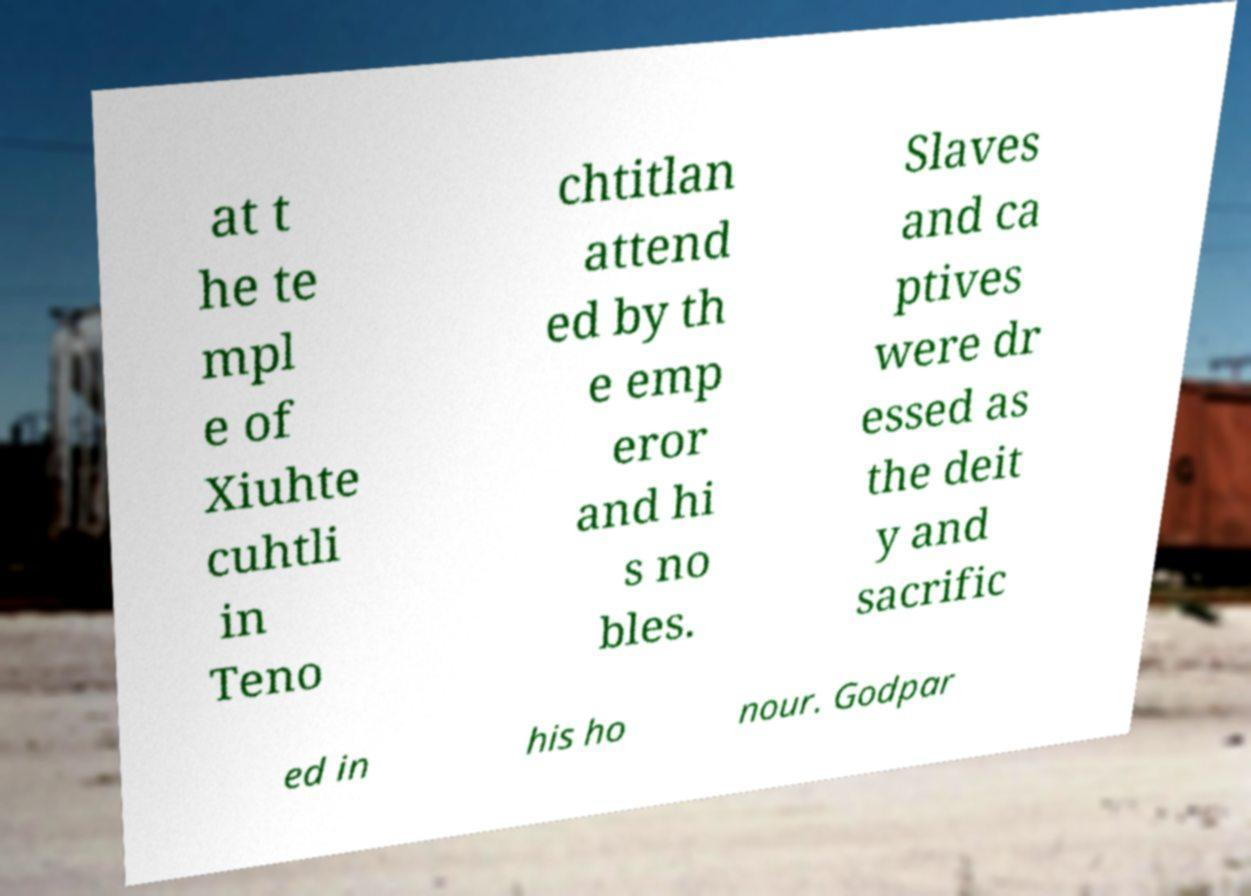What messages or text are displayed in this image? I need them in a readable, typed format. at t he te mpl e of Xiuhte cuhtli in Teno chtitlan attend ed by th e emp eror and hi s no bles. Slaves and ca ptives were dr essed as the deit y and sacrific ed in his ho nour. Godpar 